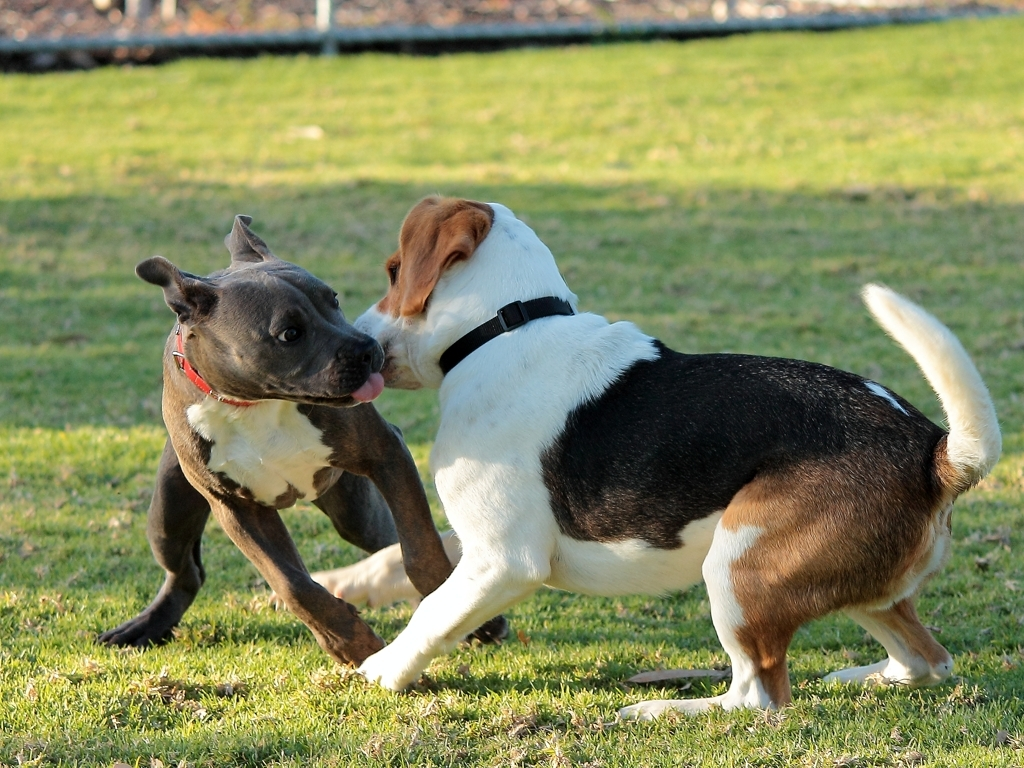What does this picture capture?
A. Still and calm atmosphere
B. The elegance of dogs
C. The surrounding environment
D. The playful antics of two dogs
Answer with the option's letter from the given choices directly. The image vividly captures option D, the playful antics of two dogs. We can see the energy and movement frozen in the moment, as one dog appears to be playfully biting at the other's face, while their bodies are positioned in a dynamic and engaged stance. This interaction typically represents the social and active nature of dogs during playtime. 